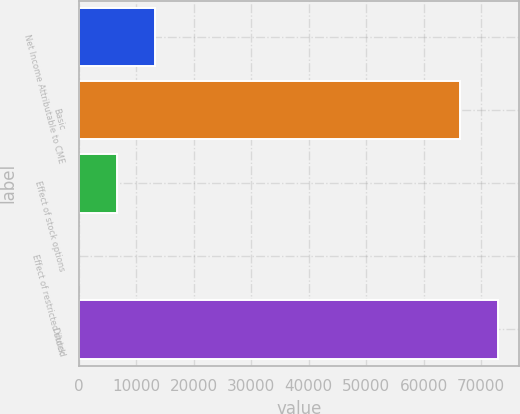Convert chart. <chart><loc_0><loc_0><loc_500><loc_500><bar_chart><fcel>Net Income Attributable to CME<fcel>Basic<fcel>Effect of stock options<fcel>Effect of restricted stock<fcel>Diluted<nl><fcel>13328.8<fcel>66366<fcel>6676.4<fcel>24<fcel>73018.4<nl></chart> 